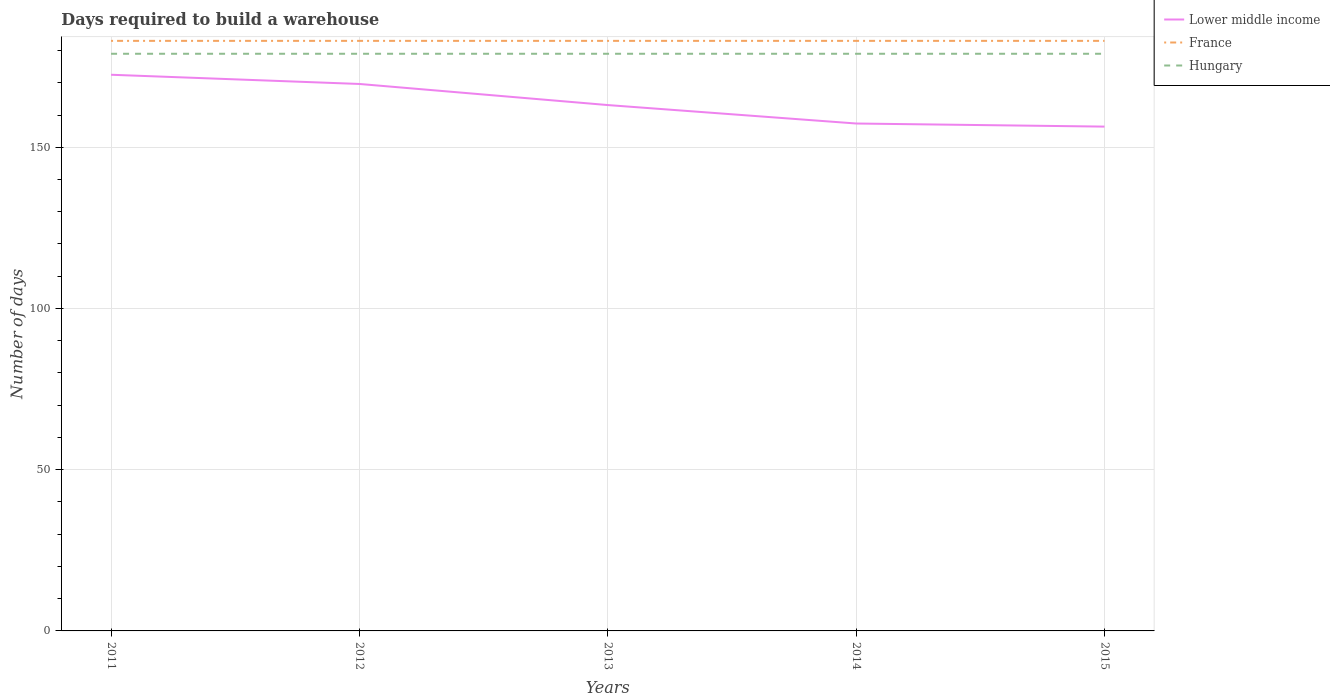How many different coloured lines are there?
Ensure brevity in your answer.  3. Across all years, what is the maximum days required to build a warehouse in in France?
Offer a very short reply. 183. What is the total days required to build a warehouse in in France in the graph?
Your response must be concise. 0. What is the difference between the highest and the second highest days required to build a warehouse in in France?
Provide a short and direct response. 0. What is the difference between the highest and the lowest days required to build a warehouse in in France?
Your answer should be compact. 0. How many lines are there?
Ensure brevity in your answer.  3. What is the difference between two consecutive major ticks on the Y-axis?
Offer a very short reply. 50. Where does the legend appear in the graph?
Offer a terse response. Top right. What is the title of the graph?
Provide a short and direct response. Days required to build a warehouse. Does "Sierra Leone" appear as one of the legend labels in the graph?
Provide a short and direct response. No. What is the label or title of the Y-axis?
Keep it short and to the point. Number of days. What is the Number of days in Lower middle income in 2011?
Offer a terse response. 172.49. What is the Number of days in France in 2011?
Provide a short and direct response. 183. What is the Number of days of Hungary in 2011?
Your response must be concise. 179. What is the Number of days in Lower middle income in 2012?
Your response must be concise. 169.63. What is the Number of days of France in 2012?
Provide a short and direct response. 183. What is the Number of days in Hungary in 2012?
Provide a short and direct response. 179. What is the Number of days in Lower middle income in 2013?
Your answer should be very brief. 163.09. What is the Number of days of France in 2013?
Your response must be concise. 183. What is the Number of days of Hungary in 2013?
Your answer should be very brief. 179. What is the Number of days of Lower middle income in 2014?
Offer a very short reply. 157.37. What is the Number of days in France in 2014?
Make the answer very short. 183. What is the Number of days of Hungary in 2014?
Your response must be concise. 179. What is the Number of days in Lower middle income in 2015?
Ensure brevity in your answer.  156.41. What is the Number of days of France in 2015?
Keep it short and to the point. 183. What is the Number of days in Hungary in 2015?
Your answer should be very brief. 179. Across all years, what is the maximum Number of days of Lower middle income?
Your response must be concise. 172.49. Across all years, what is the maximum Number of days of France?
Your answer should be very brief. 183. Across all years, what is the maximum Number of days of Hungary?
Ensure brevity in your answer.  179. Across all years, what is the minimum Number of days in Lower middle income?
Ensure brevity in your answer.  156.41. Across all years, what is the minimum Number of days in France?
Provide a succinct answer. 183. Across all years, what is the minimum Number of days in Hungary?
Make the answer very short. 179. What is the total Number of days of Lower middle income in the graph?
Offer a very short reply. 818.98. What is the total Number of days in France in the graph?
Your answer should be very brief. 915. What is the total Number of days of Hungary in the graph?
Give a very brief answer. 895. What is the difference between the Number of days in Lower middle income in 2011 and that in 2012?
Your response must be concise. 2.86. What is the difference between the Number of days of Lower middle income in 2011 and that in 2013?
Offer a very short reply. 9.4. What is the difference between the Number of days in Hungary in 2011 and that in 2013?
Your response must be concise. 0. What is the difference between the Number of days in Lower middle income in 2011 and that in 2014?
Offer a very short reply. 15.12. What is the difference between the Number of days in Hungary in 2011 and that in 2014?
Your answer should be very brief. 0. What is the difference between the Number of days of Lower middle income in 2011 and that in 2015?
Your answer should be very brief. 16.08. What is the difference between the Number of days of France in 2011 and that in 2015?
Offer a very short reply. 0. What is the difference between the Number of days of Lower middle income in 2012 and that in 2013?
Offer a very short reply. 6.54. What is the difference between the Number of days of France in 2012 and that in 2013?
Make the answer very short. 0. What is the difference between the Number of days of Hungary in 2012 and that in 2013?
Your answer should be very brief. 0. What is the difference between the Number of days in Lower middle income in 2012 and that in 2014?
Ensure brevity in your answer.  12.26. What is the difference between the Number of days in Lower middle income in 2012 and that in 2015?
Offer a very short reply. 13.22. What is the difference between the Number of days in France in 2012 and that in 2015?
Provide a succinct answer. 0. What is the difference between the Number of days of Hungary in 2012 and that in 2015?
Provide a short and direct response. 0. What is the difference between the Number of days in Lower middle income in 2013 and that in 2014?
Provide a short and direct response. 5.72. What is the difference between the Number of days in France in 2013 and that in 2014?
Your answer should be compact. 0. What is the difference between the Number of days of Hungary in 2013 and that in 2014?
Make the answer very short. 0. What is the difference between the Number of days in Lower middle income in 2013 and that in 2015?
Make the answer very short. 6.68. What is the difference between the Number of days in Lower middle income in 2014 and that in 2015?
Your answer should be very brief. 0.96. What is the difference between the Number of days of France in 2014 and that in 2015?
Ensure brevity in your answer.  0. What is the difference between the Number of days in Hungary in 2014 and that in 2015?
Give a very brief answer. 0. What is the difference between the Number of days in Lower middle income in 2011 and the Number of days in France in 2012?
Your answer should be compact. -10.51. What is the difference between the Number of days in Lower middle income in 2011 and the Number of days in Hungary in 2012?
Your answer should be compact. -6.51. What is the difference between the Number of days of Lower middle income in 2011 and the Number of days of France in 2013?
Your response must be concise. -10.51. What is the difference between the Number of days of Lower middle income in 2011 and the Number of days of Hungary in 2013?
Give a very brief answer. -6.51. What is the difference between the Number of days of France in 2011 and the Number of days of Hungary in 2013?
Your answer should be very brief. 4. What is the difference between the Number of days of Lower middle income in 2011 and the Number of days of France in 2014?
Give a very brief answer. -10.51. What is the difference between the Number of days in Lower middle income in 2011 and the Number of days in Hungary in 2014?
Give a very brief answer. -6.51. What is the difference between the Number of days of France in 2011 and the Number of days of Hungary in 2014?
Keep it short and to the point. 4. What is the difference between the Number of days of Lower middle income in 2011 and the Number of days of France in 2015?
Give a very brief answer. -10.51. What is the difference between the Number of days in Lower middle income in 2011 and the Number of days in Hungary in 2015?
Keep it short and to the point. -6.51. What is the difference between the Number of days in Lower middle income in 2012 and the Number of days in France in 2013?
Provide a succinct answer. -13.37. What is the difference between the Number of days of Lower middle income in 2012 and the Number of days of Hungary in 2013?
Your answer should be very brief. -9.37. What is the difference between the Number of days in Lower middle income in 2012 and the Number of days in France in 2014?
Offer a terse response. -13.37. What is the difference between the Number of days in Lower middle income in 2012 and the Number of days in Hungary in 2014?
Provide a short and direct response. -9.37. What is the difference between the Number of days of Lower middle income in 2012 and the Number of days of France in 2015?
Provide a succinct answer. -13.37. What is the difference between the Number of days in Lower middle income in 2012 and the Number of days in Hungary in 2015?
Offer a terse response. -9.37. What is the difference between the Number of days in Lower middle income in 2013 and the Number of days in France in 2014?
Offer a terse response. -19.91. What is the difference between the Number of days of Lower middle income in 2013 and the Number of days of Hungary in 2014?
Your response must be concise. -15.91. What is the difference between the Number of days of France in 2013 and the Number of days of Hungary in 2014?
Ensure brevity in your answer.  4. What is the difference between the Number of days of Lower middle income in 2013 and the Number of days of France in 2015?
Offer a terse response. -19.91. What is the difference between the Number of days in Lower middle income in 2013 and the Number of days in Hungary in 2015?
Keep it short and to the point. -15.91. What is the difference between the Number of days of Lower middle income in 2014 and the Number of days of France in 2015?
Keep it short and to the point. -25.63. What is the difference between the Number of days in Lower middle income in 2014 and the Number of days in Hungary in 2015?
Offer a terse response. -21.63. What is the difference between the Number of days of France in 2014 and the Number of days of Hungary in 2015?
Your answer should be compact. 4. What is the average Number of days of Lower middle income per year?
Offer a very short reply. 163.8. What is the average Number of days in France per year?
Your answer should be very brief. 183. What is the average Number of days in Hungary per year?
Give a very brief answer. 179. In the year 2011, what is the difference between the Number of days of Lower middle income and Number of days of France?
Offer a terse response. -10.51. In the year 2011, what is the difference between the Number of days in Lower middle income and Number of days in Hungary?
Make the answer very short. -6.51. In the year 2012, what is the difference between the Number of days of Lower middle income and Number of days of France?
Your answer should be compact. -13.37. In the year 2012, what is the difference between the Number of days of Lower middle income and Number of days of Hungary?
Offer a terse response. -9.37. In the year 2013, what is the difference between the Number of days of Lower middle income and Number of days of France?
Provide a short and direct response. -19.91. In the year 2013, what is the difference between the Number of days of Lower middle income and Number of days of Hungary?
Your answer should be compact. -15.91. In the year 2013, what is the difference between the Number of days in France and Number of days in Hungary?
Your answer should be very brief. 4. In the year 2014, what is the difference between the Number of days of Lower middle income and Number of days of France?
Provide a short and direct response. -25.63. In the year 2014, what is the difference between the Number of days of Lower middle income and Number of days of Hungary?
Keep it short and to the point. -21.63. In the year 2014, what is the difference between the Number of days in France and Number of days in Hungary?
Ensure brevity in your answer.  4. In the year 2015, what is the difference between the Number of days of Lower middle income and Number of days of France?
Provide a succinct answer. -26.59. In the year 2015, what is the difference between the Number of days in Lower middle income and Number of days in Hungary?
Provide a short and direct response. -22.59. What is the ratio of the Number of days of Lower middle income in 2011 to that in 2012?
Your answer should be very brief. 1.02. What is the ratio of the Number of days of France in 2011 to that in 2012?
Provide a short and direct response. 1. What is the ratio of the Number of days in Lower middle income in 2011 to that in 2013?
Your response must be concise. 1.06. What is the ratio of the Number of days of Lower middle income in 2011 to that in 2014?
Offer a terse response. 1.1. What is the ratio of the Number of days in Hungary in 2011 to that in 2014?
Your answer should be compact. 1. What is the ratio of the Number of days in Lower middle income in 2011 to that in 2015?
Ensure brevity in your answer.  1.1. What is the ratio of the Number of days of France in 2011 to that in 2015?
Ensure brevity in your answer.  1. What is the ratio of the Number of days in Hungary in 2011 to that in 2015?
Give a very brief answer. 1. What is the ratio of the Number of days in Lower middle income in 2012 to that in 2013?
Offer a very short reply. 1.04. What is the ratio of the Number of days of France in 2012 to that in 2013?
Offer a very short reply. 1. What is the ratio of the Number of days in Hungary in 2012 to that in 2013?
Your response must be concise. 1. What is the ratio of the Number of days of Lower middle income in 2012 to that in 2014?
Your response must be concise. 1.08. What is the ratio of the Number of days in France in 2012 to that in 2014?
Your answer should be very brief. 1. What is the ratio of the Number of days of Lower middle income in 2012 to that in 2015?
Offer a terse response. 1.08. What is the ratio of the Number of days of France in 2012 to that in 2015?
Keep it short and to the point. 1. What is the ratio of the Number of days of Hungary in 2012 to that in 2015?
Make the answer very short. 1. What is the ratio of the Number of days of Lower middle income in 2013 to that in 2014?
Your answer should be very brief. 1.04. What is the ratio of the Number of days of France in 2013 to that in 2014?
Your response must be concise. 1. What is the ratio of the Number of days in Lower middle income in 2013 to that in 2015?
Your response must be concise. 1.04. What is the ratio of the Number of days in France in 2013 to that in 2015?
Your answer should be very brief. 1. What is the difference between the highest and the second highest Number of days of Lower middle income?
Offer a terse response. 2.86. What is the difference between the highest and the second highest Number of days in France?
Give a very brief answer. 0. What is the difference between the highest and the second highest Number of days in Hungary?
Offer a very short reply. 0. What is the difference between the highest and the lowest Number of days of Lower middle income?
Keep it short and to the point. 16.08. What is the difference between the highest and the lowest Number of days in France?
Offer a terse response. 0. 